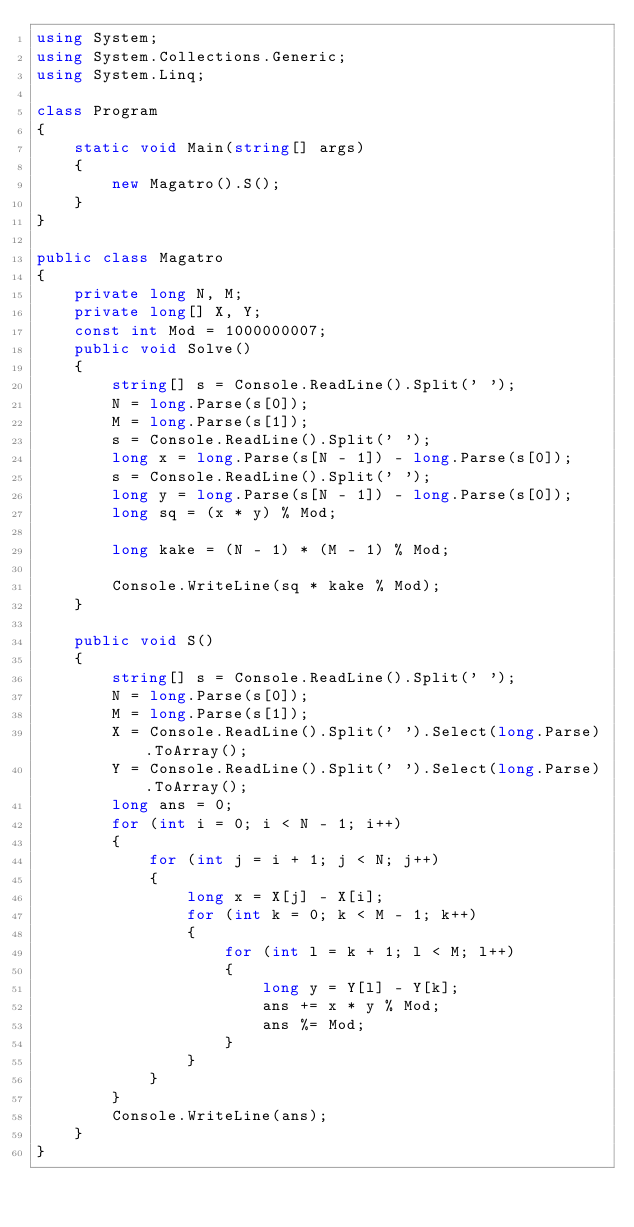Convert code to text. <code><loc_0><loc_0><loc_500><loc_500><_C#_>using System;
using System.Collections.Generic;
using System.Linq;

class Program
{
    static void Main(string[] args)
    {
        new Magatro().S();
    }
}

public class Magatro
{
    private long N, M;
    private long[] X, Y;
    const int Mod = 1000000007;
    public void Solve()
    {
        string[] s = Console.ReadLine().Split(' ');
        N = long.Parse(s[0]);
        M = long.Parse(s[1]);
        s = Console.ReadLine().Split(' ');
        long x = long.Parse(s[N - 1]) - long.Parse(s[0]);
        s = Console.ReadLine().Split(' ');
        long y = long.Parse(s[N - 1]) - long.Parse(s[0]);
        long sq = (x * y) % Mod;

        long kake = (N - 1) * (M - 1) % Mod;

        Console.WriteLine(sq * kake % Mod);
    }

    public void S()
    {
        string[] s = Console.ReadLine().Split(' ');
        N = long.Parse(s[0]);
        M = long.Parse(s[1]);
        X = Console.ReadLine().Split(' ').Select(long.Parse).ToArray();
        Y = Console.ReadLine().Split(' ').Select(long.Parse).ToArray();
        long ans = 0;
        for (int i = 0; i < N - 1; i++)
        {
            for (int j = i + 1; j < N; j++)
            {
                long x = X[j] - X[i];
                for (int k = 0; k < M - 1; k++)
                {
                    for (int l = k + 1; l < M; l++)
                    {
                        long y = Y[l] - Y[k];
                        ans += x * y % Mod;
                        ans %= Mod;
                    }
                }
            }
        }
        Console.WriteLine(ans);
    }
}</code> 